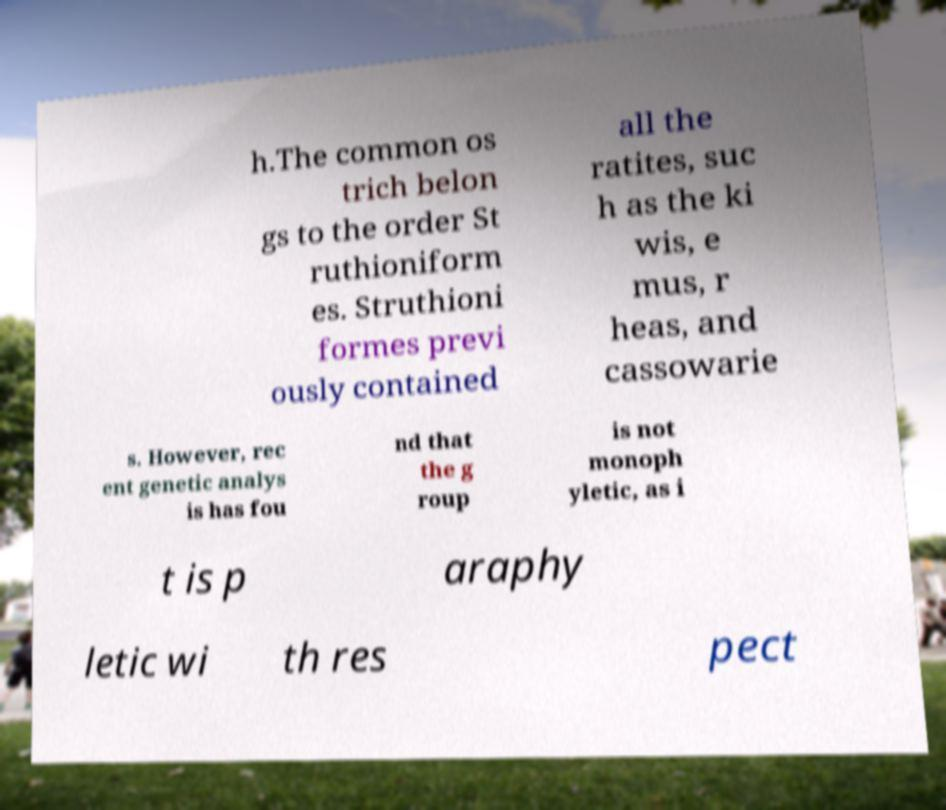Can you accurately transcribe the text from the provided image for me? h.The common os trich belon gs to the order St ruthioniform es. Struthioni formes previ ously contained all the ratites, suc h as the ki wis, e mus, r heas, and cassowarie s. However, rec ent genetic analys is has fou nd that the g roup is not monoph yletic, as i t is p araphy letic wi th res pect 